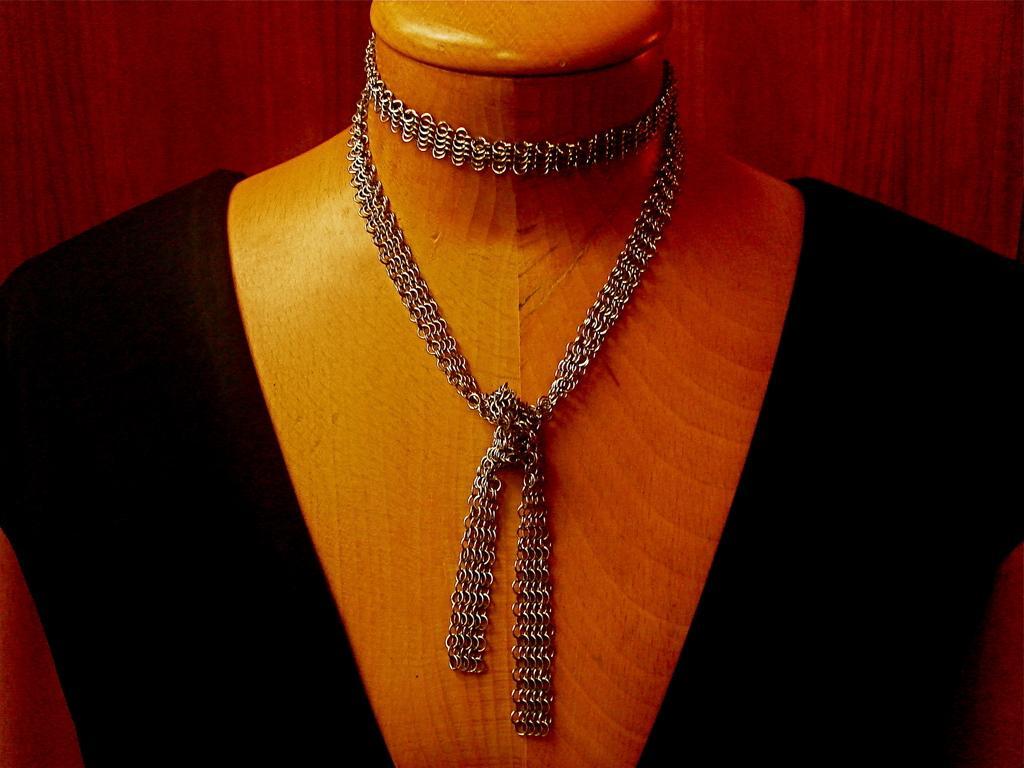Can you describe this image briefly? In this image there is a depiction of a person's body without a face, wearing a black color dress and there is like a chain on the neck. 